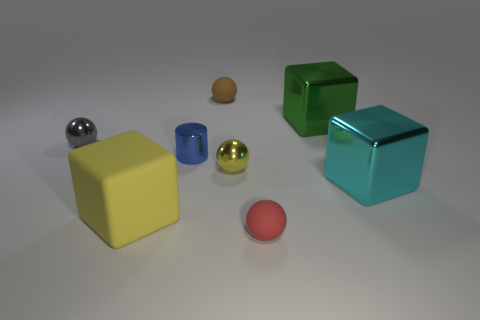Could you describe the lighting and shadows in the image? Certainly! The image is lit from above, as indicated by the soft shadows cast directly underneath the objects. The shadows are slightly elongated, implying that the light source, while not directly overhead, is relatively close to being so. The reflective surfaces of the metallic objects catch the light strongly and exhibit highlights, whereas the more matte surfaces scatter the light, resulting in a more diffused appearance. 